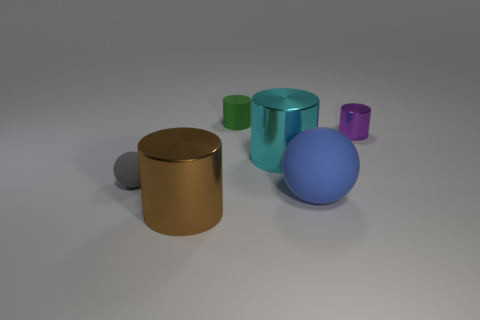What is the shape of the brown thing to the left of the sphere on the right side of the big brown metal cylinder?
Your answer should be very brief. Cylinder. What number of objects are either big green balls or big shiny cylinders that are behind the gray object?
Give a very brief answer. 1. The big metal cylinder behind the matte ball in front of the matte ball on the left side of the small green matte cylinder is what color?
Your answer should be very brief. Cyan. What material is the small green object that is the same shape as the cyan thing?
Ensure brevity in your answer.  Rubber. The tiny sphere has what color?
Your answer should be very brief. Gray. Does the small rubber ball have the same color as the tiny metallic object?
Give a very brief answer. No. How many metallic objects are either purple cylinders or large cyan things?
Ensure brevity in your answer.  2. There is a tiny object that is behind the metal cylinder that is to the right of the blue thing; are there any large cyan objects that are to the right of it?
Keep it short and to the point. Yes. There is a green cylinder that is made of the same material as the tiny ball; what is its size?
Make the answer very short. Small. There is a large blue matte sphere; are there any small purple shiny cylinders in front of it?
Offer a very short reply. No. 